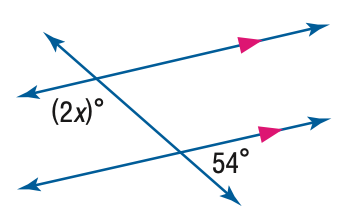Answer the mathemtical geometry problem and directly provide the correct option letter.
Question: Find the value of the variable x in the figure.
Choices: A: 27 B: 54 C: 63 D: 126 C 